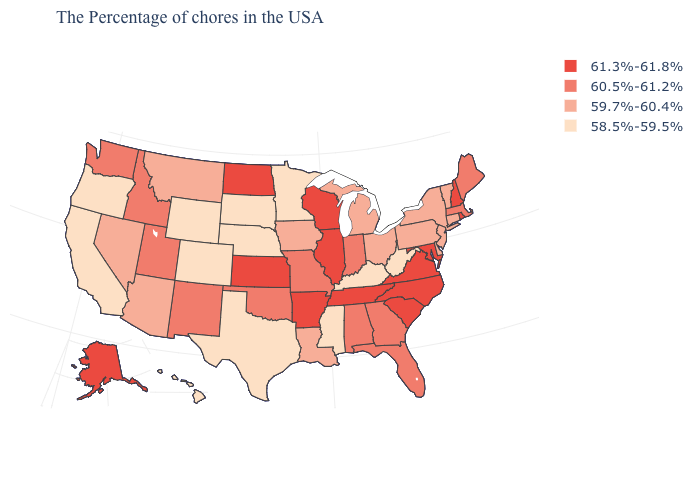What is the lowest value in states that border California?
Give a very brief answer. 58.5%-59.5%. Among the states that border Vermont , does New York have the lowest value?
Keep it brief. Yes. Which states have the highest value in the USA?
Short answer required. Rhode Island, New Hampshire, Maryland, Virginia, North Carolina, South Carolina, Tennessee, Wisconsin, Illinois, Arkansas, Kansas, North Dakota, Alaska. Which states have the lowest value in the South?
Concise answer only. West Virginia, Kentucky, Mississippi, Texas. What is the value of Louisiana?
Give a very brief answer. 59.7%-60.4%. What is the lowest value in the USA?
Quick response, please. 58.5%-59.5%. Which states have the lowest value in the West?
Write a very short answer. Wyoming, Colorado, California, Oregon, Hawaii. Which states have the lowest value in the USA?
Be succinct. West Virginia, Kentucky, Mississippi, Minnesota, Nebraska, Texas, South Dakota, Wyoming, Colorado, California, Oregon, Hawaii. Does New Mexico have a higher value than Indiana?
Quick response, please. No. What is the highest value in the Northeast ?
Write a very short answer. 61.3%-61.8%. Among the states that border Colorado , which have the highest value?
Be succinct. Kansas. What is the value of Michigan?
Quick response, please. 59.7%-60.4%. What is the value of Vermont?
Concise answer only. 59.7%-60.4%. Name the states that have a value in the range 58.5%-59.5%?
Quick response, please. West Virginia, Kentucky, Mississippi, Minnesota, Nebraska, Texas, South Dakota, Wyoming, Colorado, California, Oregon, Hawaii. Does the map have missing data?
Quick response, please. No. 